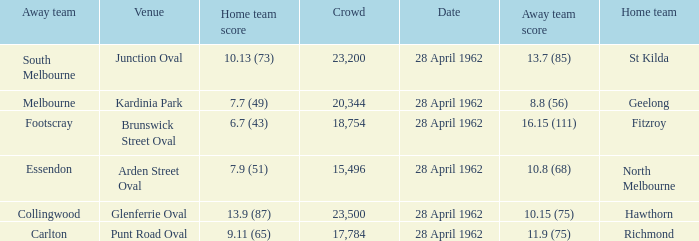At what venue did an away team score 10.15 (75)? Glenferrie Oval. 